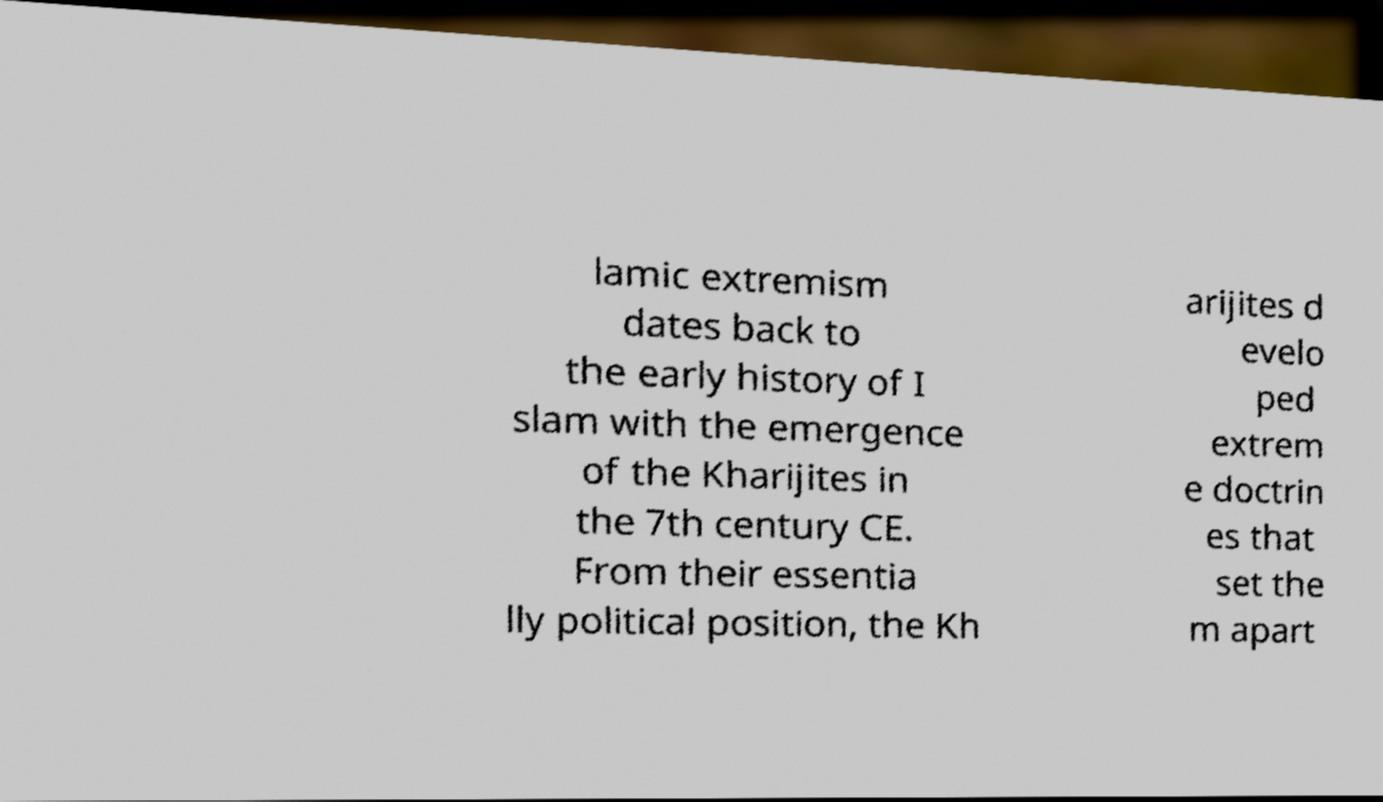Please identify and transcribe the text found in this image. lamic extremism dates back to the early history of I slam with the emergence of the Kharijites in the 7th century CE. From their essentia lly political position, the Kh arijites d evelo ped extrem e doctrin es that set the m apart 